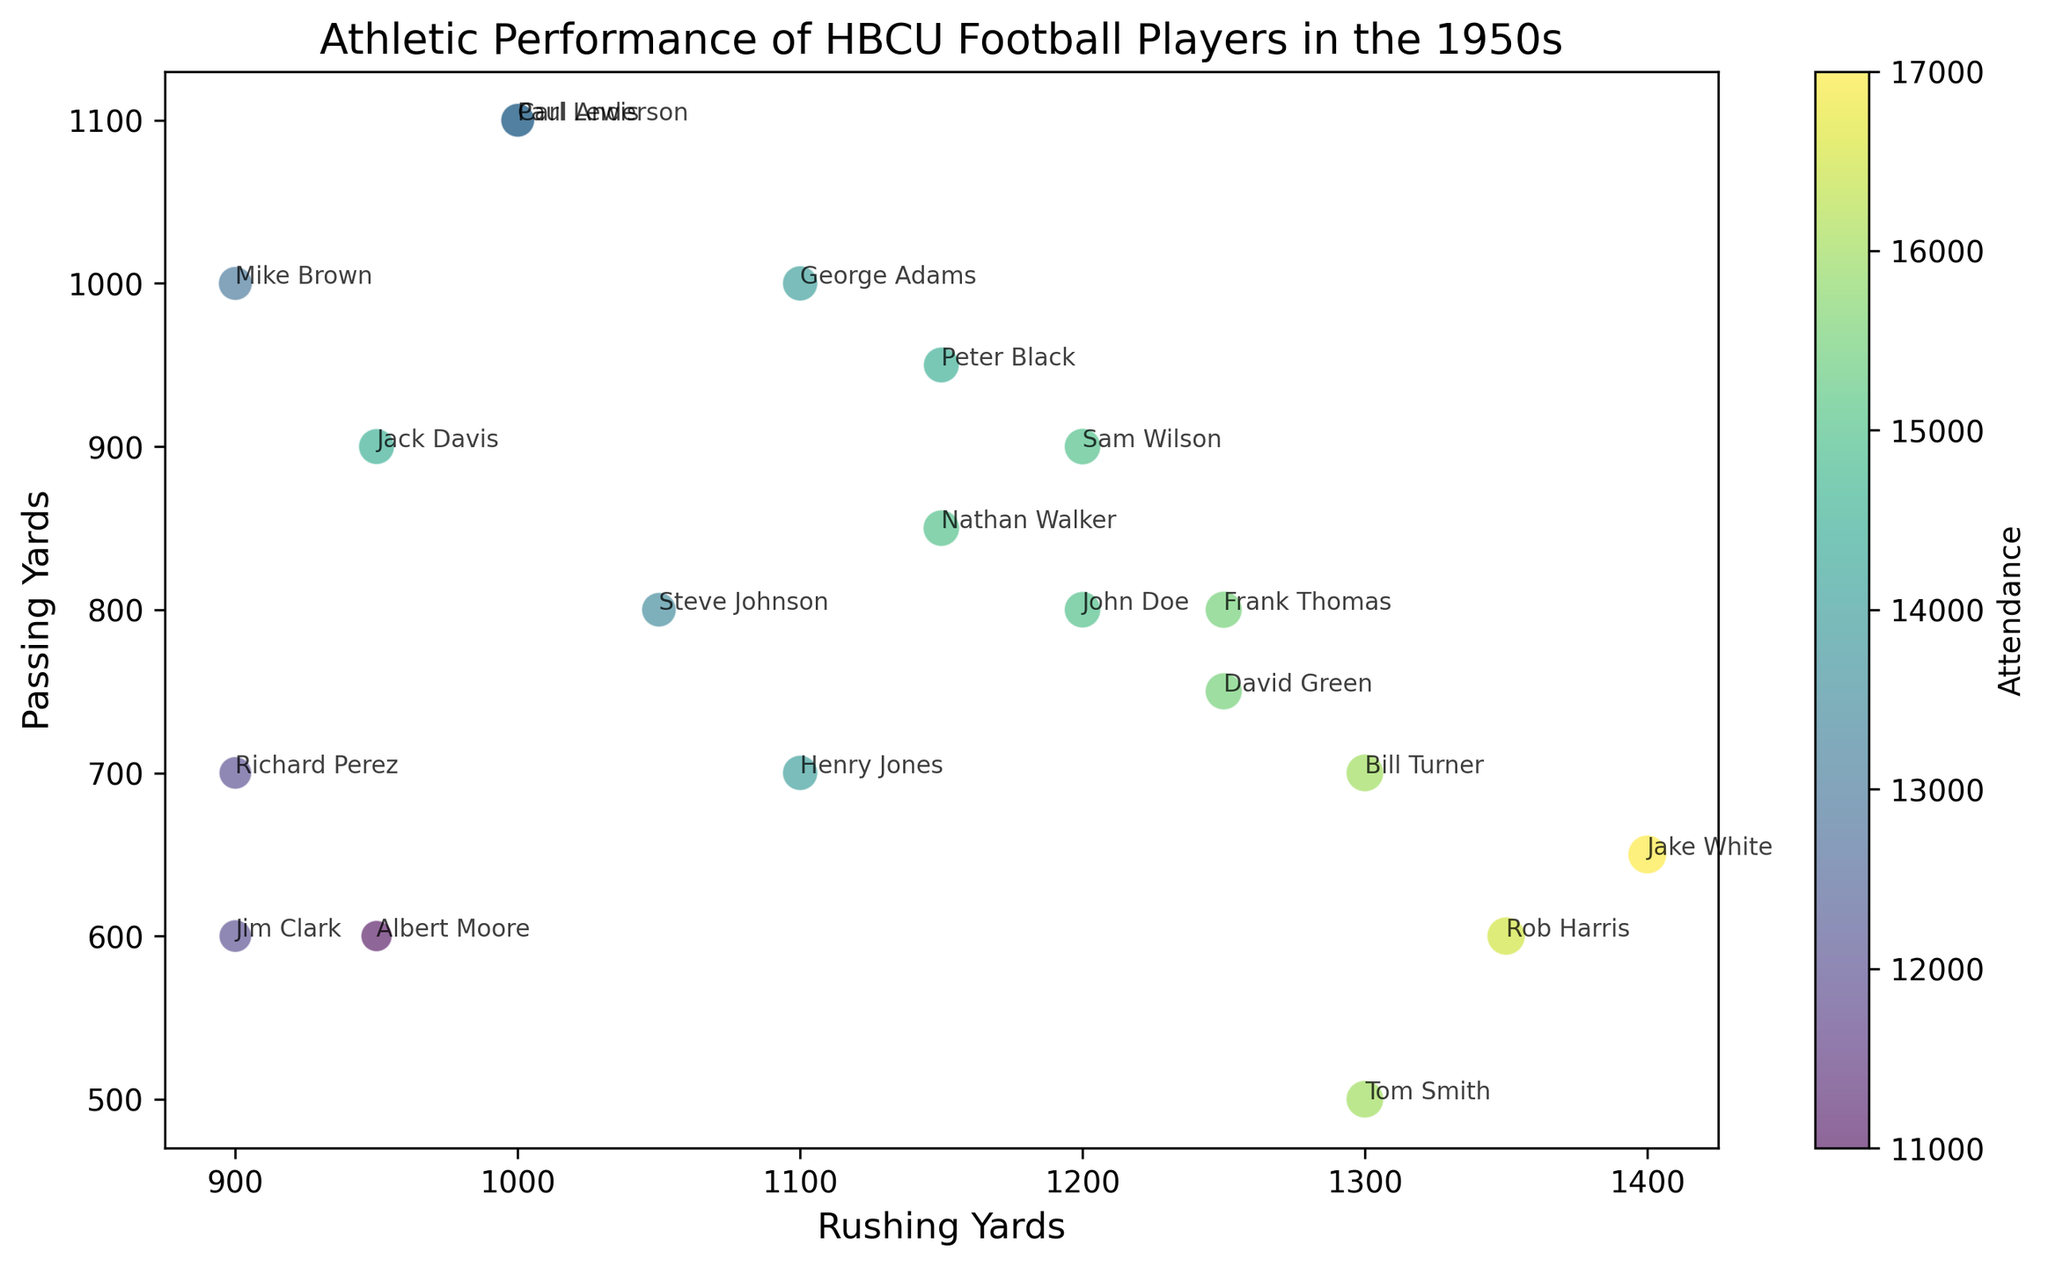Which player has the highest attendance? The player with the highest attendance can be found by looking for the largest circle, as the size of the points is scaled according to attendance.
Answer: Jake White How many players have more than 1200 rushing yards? To find this, count the number of data points (circles) that are positioned to the right of 1200 on the x-axis.
Answer: 5 Which player has a combination of the highest rushing yards and passing yards? To find the player with the highest combination, look at both axes; the player closest to the top right corner has the highest combination of both metrics.
Answer: Jake White Which school had the lowest attendance? To find the school with the lowest attendance, look for the smallest circle on the plot.
Answer: Lincoln University Is there a player with more than 1000 rushing yards and more than 1000 passing yards? Check for any circle positioned to the right of 1000 on the x-axis and above 1000 on the y-axis.
Answer: No Compare the attendance for the player with the most passing yards to the player with the most rushing yards. The player with the most passing yards has 1100 (Paul Anderson) and the one with the most rushing yards has 1400 (Jake White). Compare their circle sizes.
Answer: Paul Anderson: 13000, Jake White: 17000 How many players had more than 15000 attendance at their games? Count the number of circles with a color corresponding to attendance values above 15000, which is in the higher range of the color scale.
Answer: 5 What color corresponds to the highest attendance in the plot and which player does it represent? Look at the color scale and identify the darkest (or most vibrant) color. Then, find the corresponding circle in the scatter plot.
Answer: Dark green, Jake White Who had more rushing yards: the player from Bethune-Cookman or the player from Hampton University? Compare the position of the circles representing these players along the x-axis to see which is further to the right.
Answer: Bethune-Cookman (Bill Turner) Which player had fewer than 1000 rushing yards but more than 750 passing yards? Find the circle positioned to the left of 1000 on the x-axis and above 750 on the y-axis.
Answer: Mike Brown 